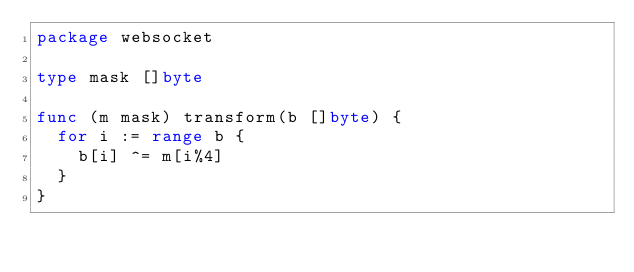Convert code to text. <code><loc_0><loc_0><loc_500><loc_500><_Go_>package websocket

type mask []byte

func (m mask) transform(b []byte) {
	for i := range b {
		b[i] ^= m[i%4]
	}
}
</code> 